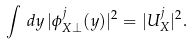Convert formula to latex. <formula><loc_0><loc_0><loc_500><loc_500>\int \, d y \, | \phi ^ { j } _ { X \perp } ( y ) | ^ { 2 } = | U _ { X } ^ { j } | ^ { 2 } .</formula> 